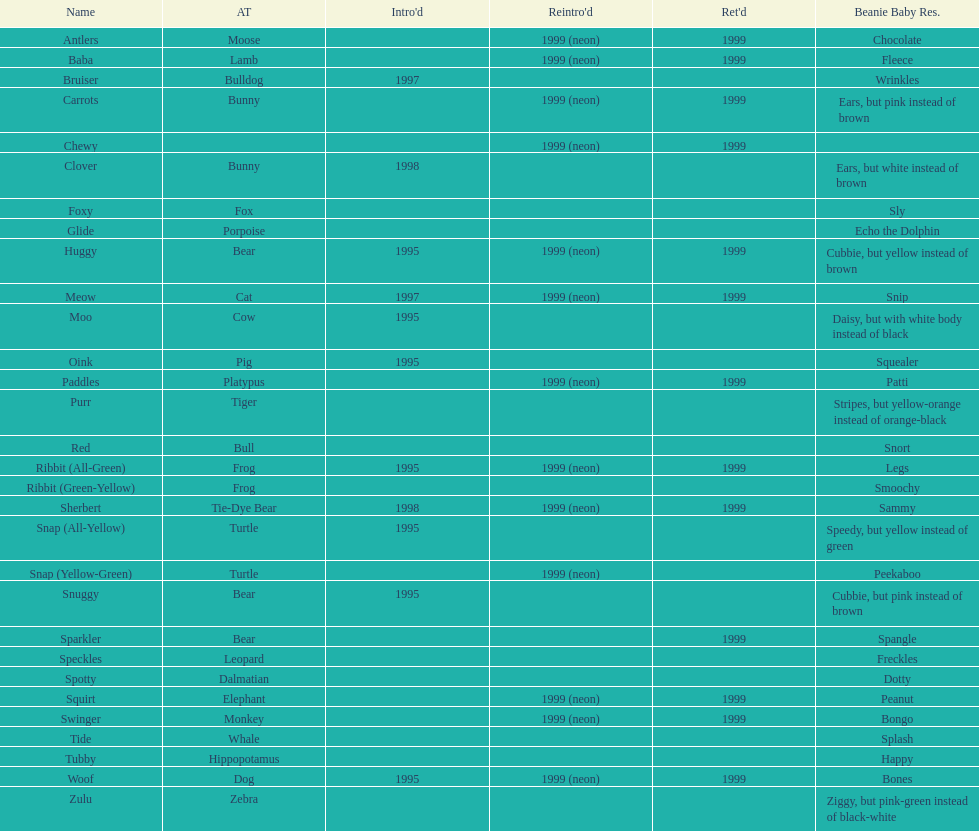Write the full table. {'header': ['Name', 'AT', "Intro'd", "Reintro'd", "Ret'd", 'Beanie Baby Res.'], 'rows': [['Antlers', 'Moose', '', '1999 (neon)', '1999', 'Chocolate'], ['Baba', 'Lamb', '', '1999 (neon)', '1999', 'Fleece'], ['Bruiser', 'Bulldog', '1997', '', '', 'Wrinkles'], ['Carrots', 'Bunny', '', '1999 (neon)', '1999', 'Ears, but pink instead of brown'], ['Chewy', '', '', '1999 (neon)', '1999', ''], ['Clover', 'Bunny', '1998', '', '', 'Ears, but white instead of brown'], ['Foxy', 'Fox', '', '', '', 'Sly'], ['Glide', 'Porpoise', '', '', '', 'Echo the Dolphin'], ['Huggy', 'Bear', '1995', '1999 (neon)', '1999', 'Cubbie, but yellow instead of brown'], ['Meow', 'Cat', '1997', '1999 (neon)', '1999', 'Snip'], ['Moo', 'Cow', '1995', '', '', 'Daisy, but with white body instead of black'], ['Oink', 'Pig', '1995', '', '', 'Squealer'], ['Paddles', 'Platypus', '', '1999 (neon)', '1999', 'Patti'], ['Purr', 'Tiger', '', '', '', 'Stripes, but yellow-orange instead of orange-black'], ['Red', 'Bull', '', '', '', 'Snort'], ['Ribbit (All-Green)', 'Frog', '1995', '1999 (neon)', '1999', 'Legs'], ['Ribbit (Green-Yellow)', 'Frog', '', '', '', 'Smoochy'], ['Sherbert', 'Tie-Dye Bear', '1998', '1999 (neon)', '1999', 'Sammy'], ['Snap (All-Yellow)', 'Turtle', '1995', '', '', 'Speedy, but yellow instead of green'], ['Snap (Yellow-Green)', 'Turtle', '', '1999 (neon)', '', 'Peekaboo'], ['Snuggy', 'Bear', '1995', '', '', 'Cubbie, but pink instead of brown'], ['Sparkler', 'Bear', '', '', '1999', 'Spangle'], ['Speckles', 'Leopard', '', '', '', 'Freckles'], ['Spotty', 'Dalmatian', '', '', '', 'Dotty'], ['Squirt', 'Elephant', '', '1999 (neon)', '1999', 'Peanut'], ['Swinger', 'Monkey', '', '1999 (neon)', '1999', 'Bongo'], ['Tide', 'Whale', '', '', '', 'Splash'], ['Tubby', 'Hippopotamus', '', '', '', 'Happy'], ['Woof', 'Dog', '1995', '1999 (neon)', '1999', 'Bones'], ['Zulu', 'Zebra', '', '', '', 'Ziggy, but pink-green instead of black-white']]} Which animal type has the most pillow pals? Bear. 